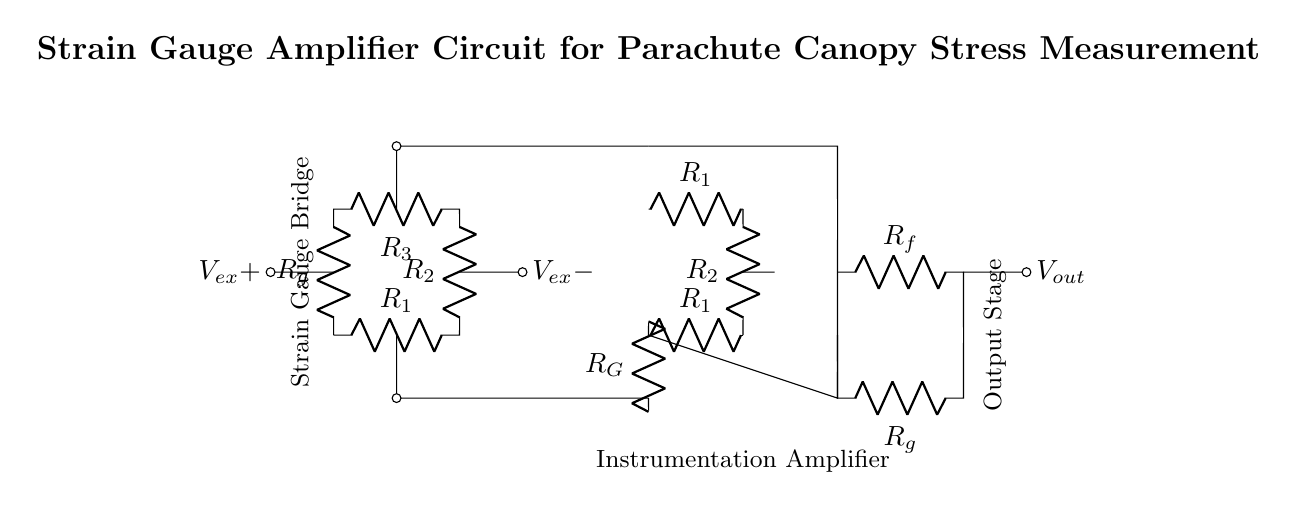What type of circuit is depicted? The circuit depicted is a strain gauge amplifier circuit, which is designed to amplify the small changes in resistance from strain gauges for measuring stress.
Answer: Strain gauge amplifier What components are part of the strain gauge bridge? The components in the strain gauge bridge are R1, R2, R3, and Rg, which form a Wheatstone bridge configuration.
Answer: R1, R2, R3, Rg What is the output voltage notation in this circuit? The output voltage is denoted as Vout, which is the final amplified voltage signal provided by the output stage of the circuit.
Answer: Vout How many operational amplifiers are used in this circuit? There is one operational amplifier used in the instrumentation amplifier section of the circuit, which functions to amplify the differential input from the strain gauge bridge.
Answer: One Explain the purpose of the resistors in the instrumentation amplifier. The resistors in the instrumentation amplifier (R1, R2, and Rg) are used to set the gain of the amplifier, affecting how much the input signal is amplified to the output. The gain is determined by the values of these resistors.
Answer: To set gain What is the role of the instrumentation amplifier in this circuit? The role of the instrumentation amplifier is to take the small differential voltage variance produced by the strain gauge bridge and amplify it to a level that can be easily read or processed, which is crucial in applications like stress measurement.
Answer: Amplify differential voltage How does the strain gauge bridge work in measuring canopy stress? The strain gauge bridge works by converting the mechanical strain experienced by the parachute canopy into a small change in resistance, which is then converted into a voltage signal by the instrumentation amplifier, allowing for the measurement of stress.
Answer: Converts strain to voltage 